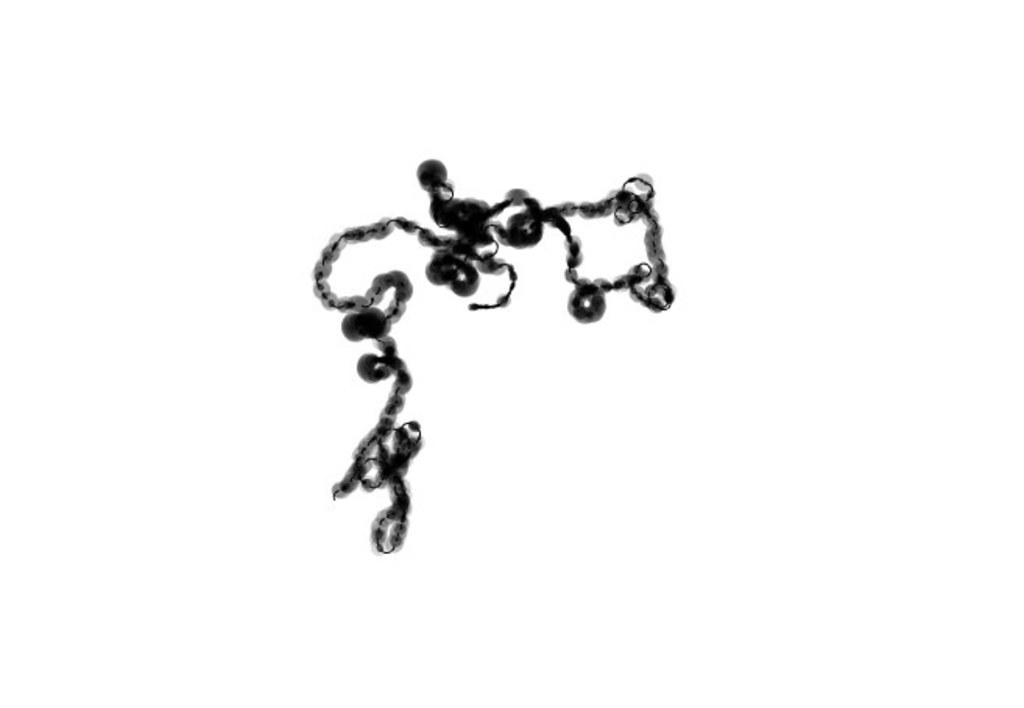How would you summarize this image in a sentence or two? This image looks like a DNA cell. It is a microscopic image. 